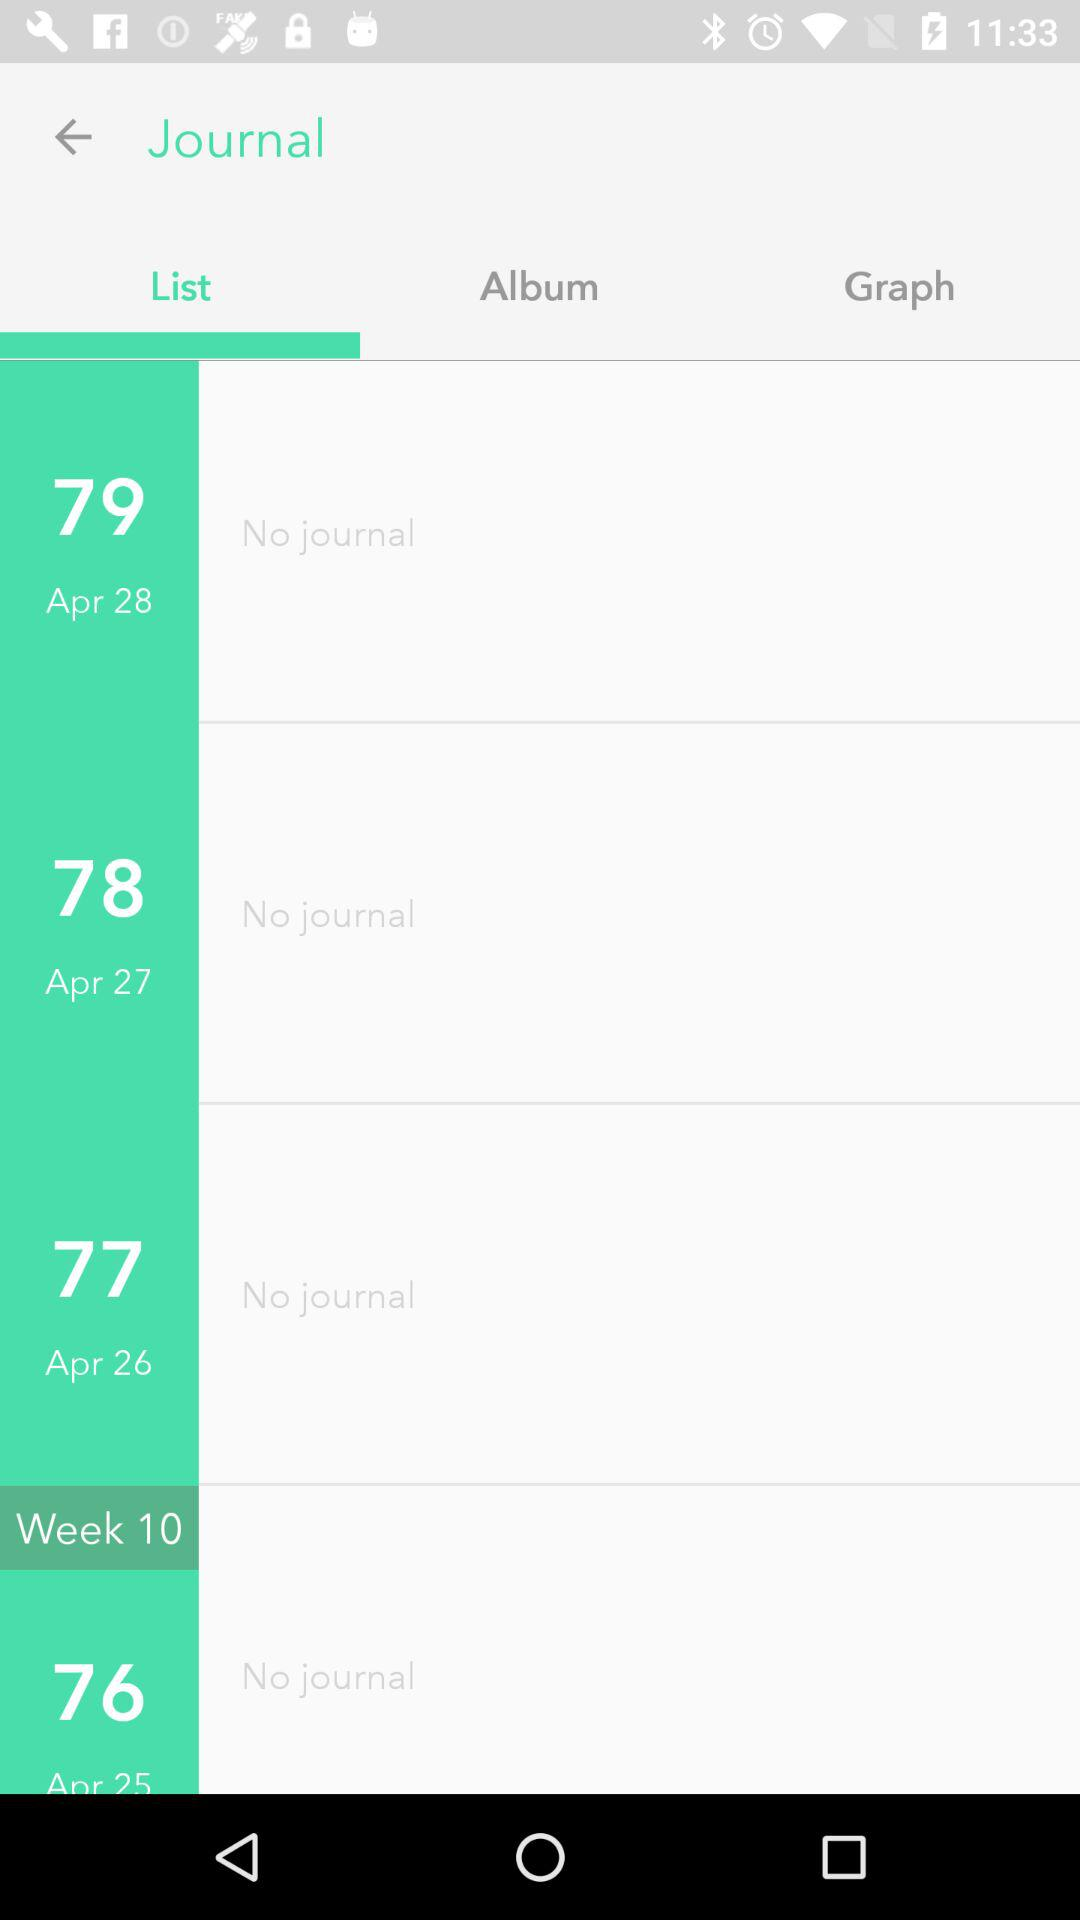Which tab is selected? The selected tab is "List". 